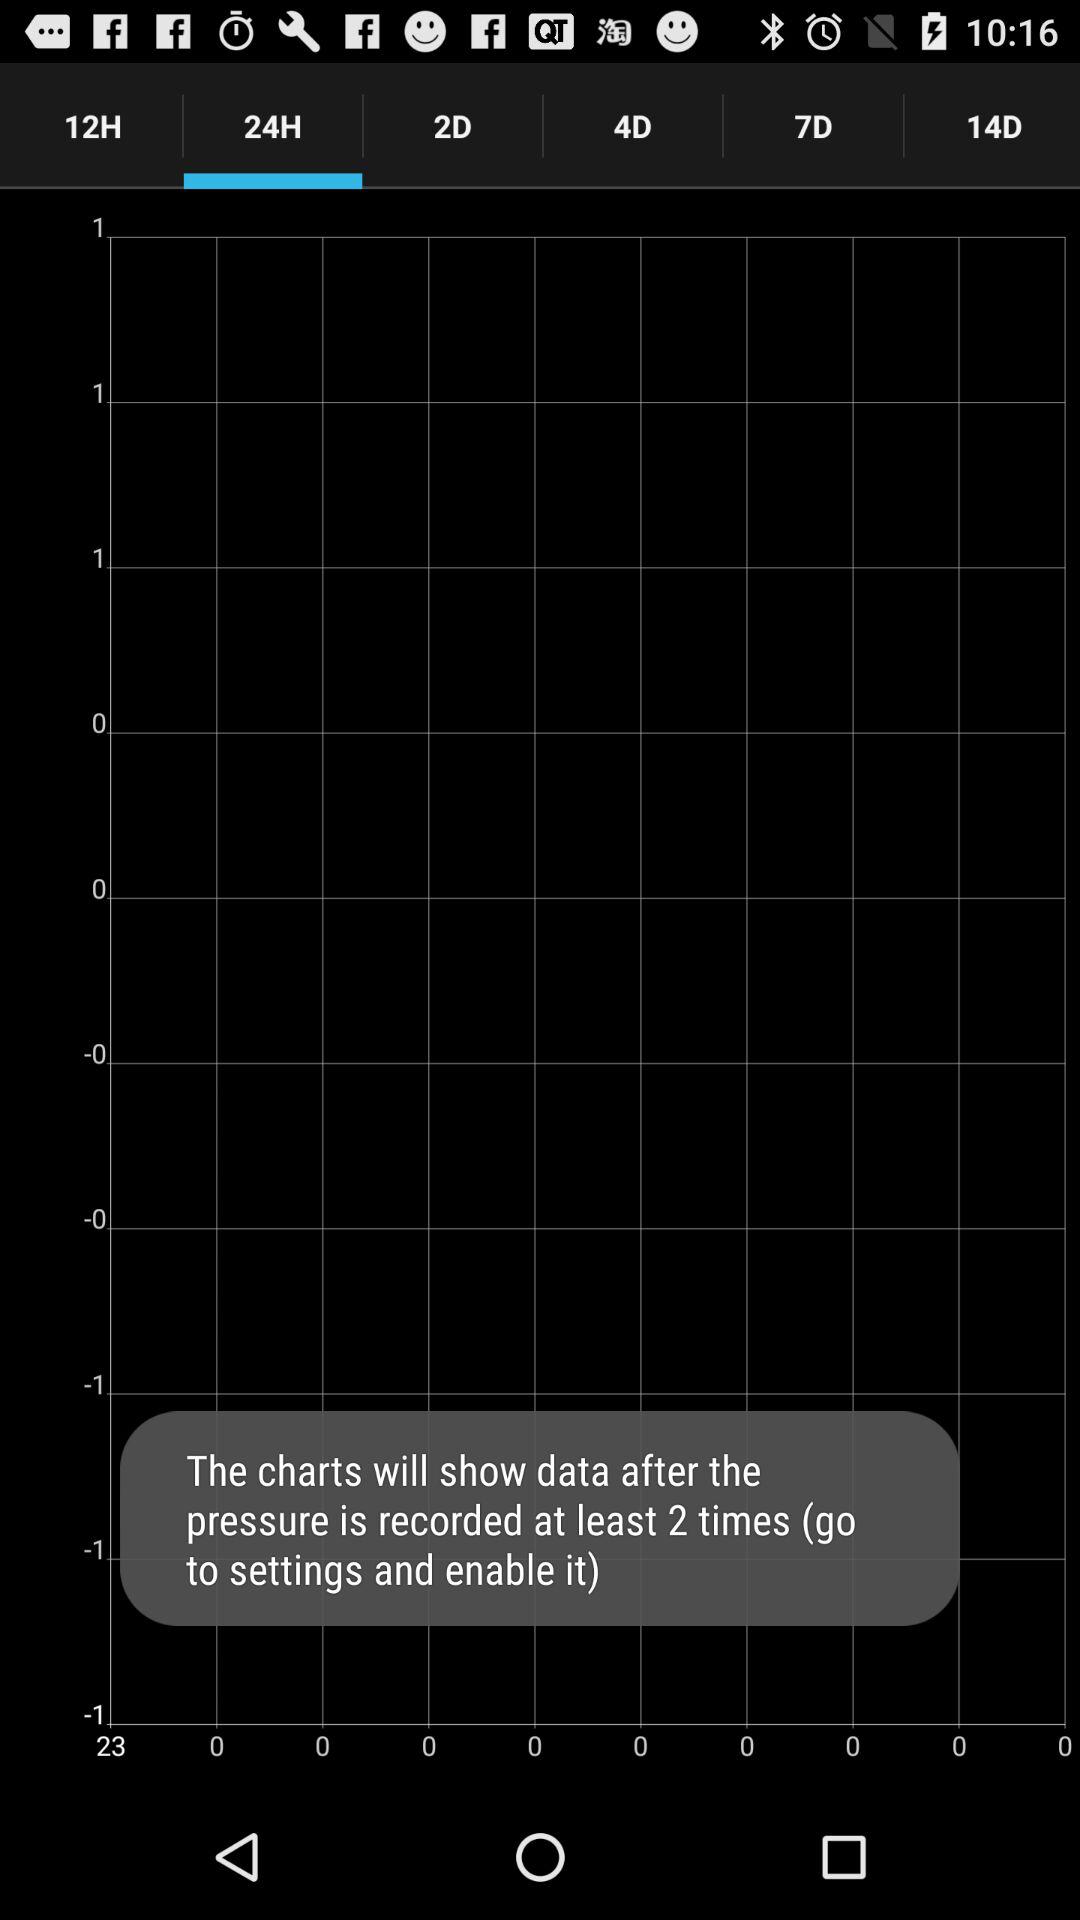Which hour has been selected? The selected hour is 24. 